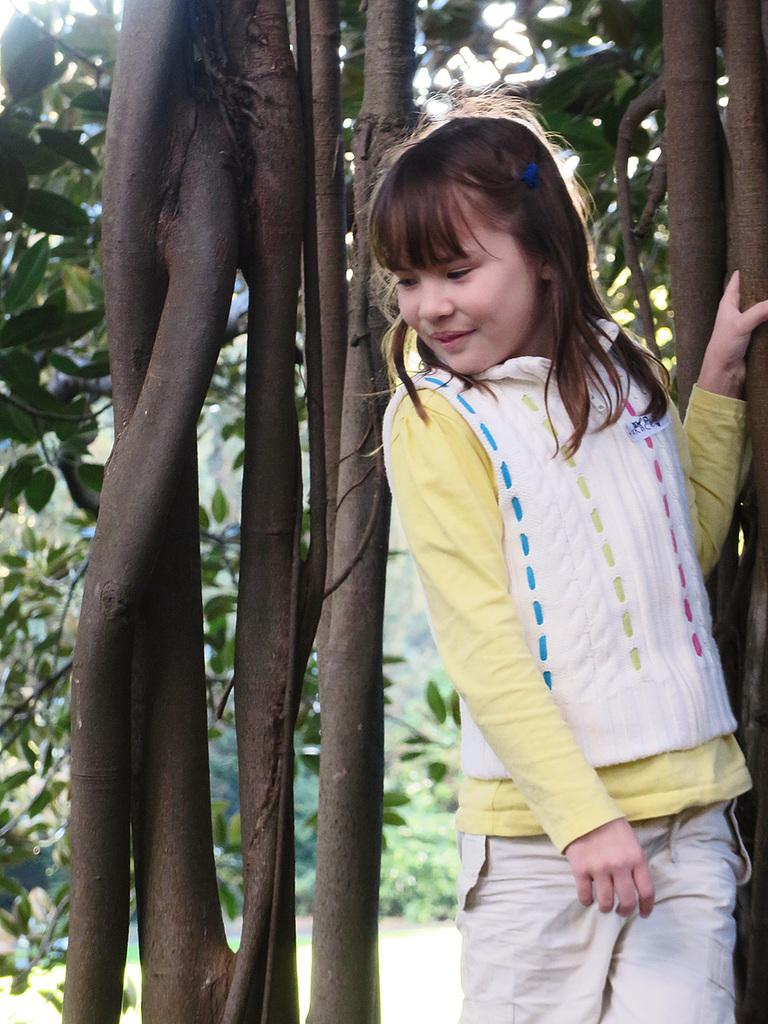Who is the main subject in the foreground of the image? There is a girl standing in the foreground of the image. On which side of the image is the girl standing? The girl is standing on the right side. What can be seen behind the girl in the image? There is a tree behind the girl. What type of environment is visible in the background of the image? There is greenery visible in the background of the image. What rule does the girl break in the image? There is no indication in the image that the girl is breaking any rules. 